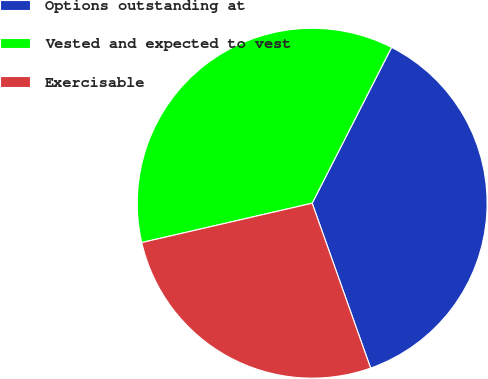Convert chart to OTSL. <chart><loc_0><loc_0><loc_500><loc_500><pie_chart><fcel>Options outstanding at<fcel>Vested and expected to vest<fcel>Exercisable<nl><fcel>37.08%<fcel>36.11%<fcel>26.81%<nl></chart> 